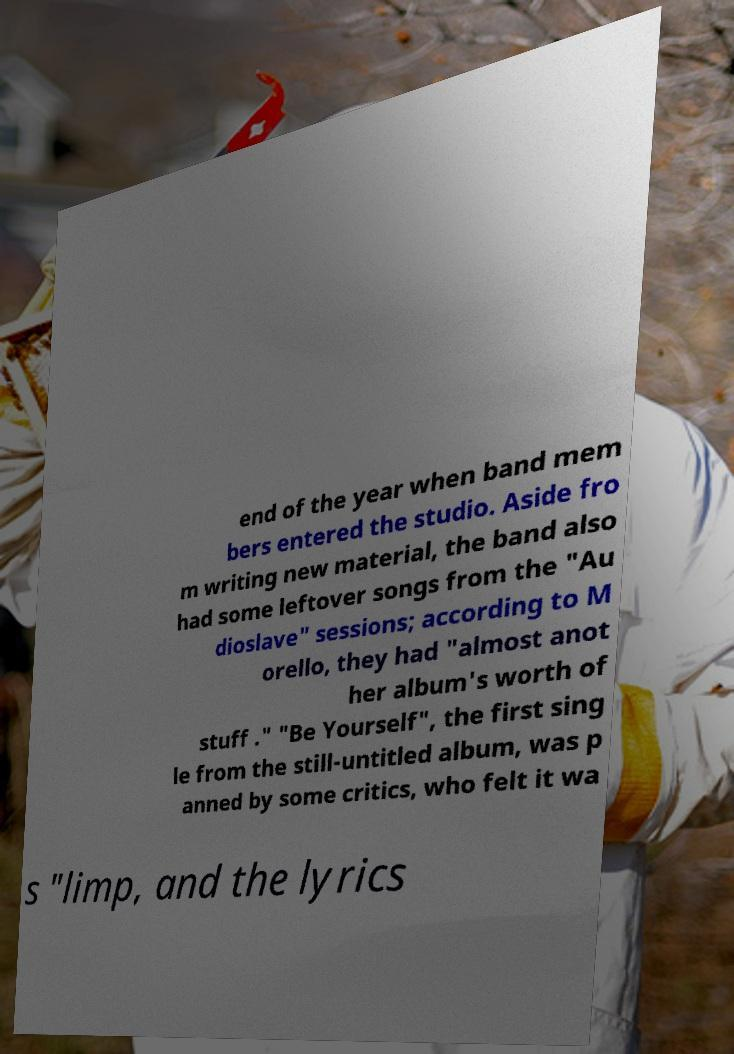There's text embedded in this image that I need extracted. Can you transcribe it verbatim? end of the year when band mem bers entered the studio. Aside fro m writing new material, the band also had some leftover songs from the "Au dioslave" sessions; according to M orello, they had "almost anot her album's worth of stuff ." "Be Yourself", the first sing le from the still-untitled album, was p anned by some critics, who felt it wa s "limp, and the lyrics 